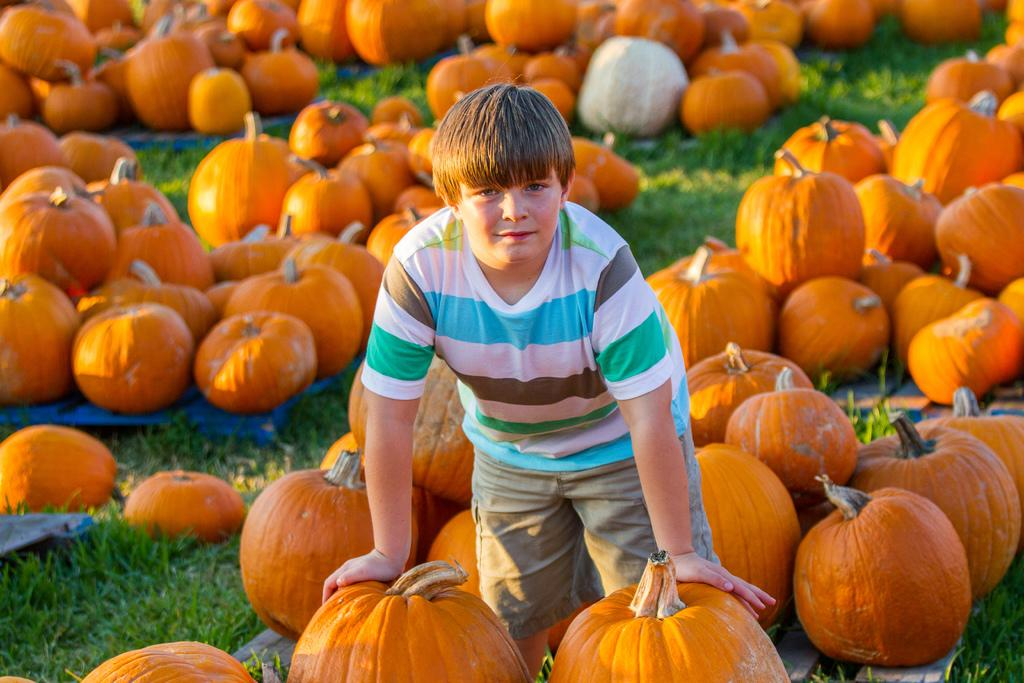What is the main subject in the center of the image? There is a boy standing in the center of the image. What objects are present in the image besides the boy? There is a group of pumpkins and plastic covers visible in the image. What type of surface is visible at the bottom of the image? Grass is visible at the bottom of the image. What type of prose can be heard being recited by the boy in the image? There is no indication in the image that the boy is reciting any prose, so it cannot be determined from the picture. 